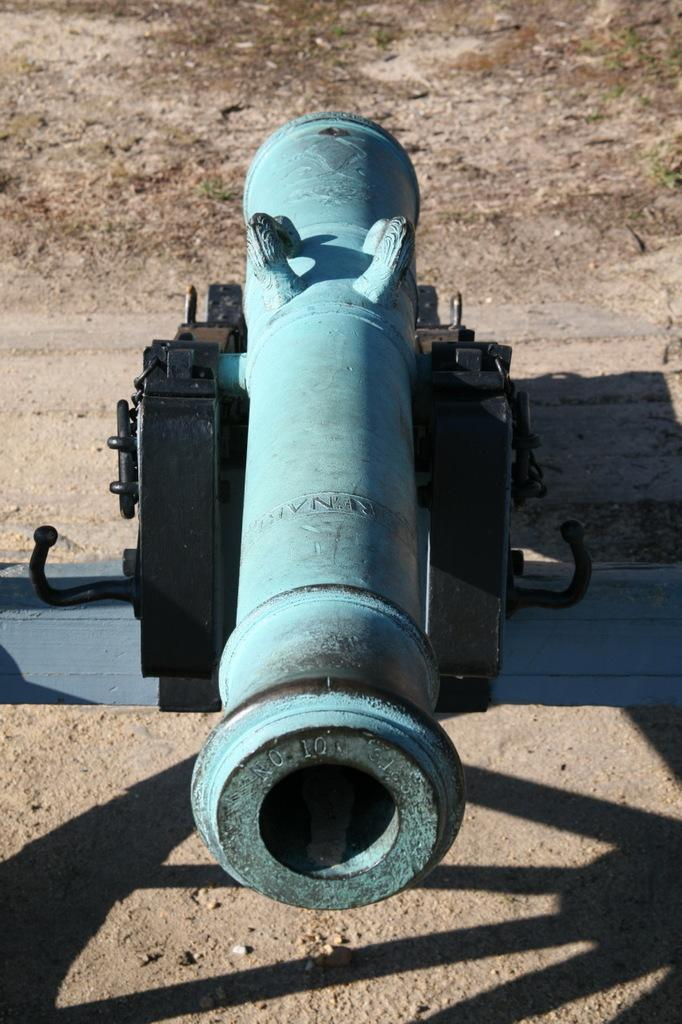What is the main object in the picture? There is a canon in the picture. What colors can be seen on the canon? The canon is blue and black in color. Where is the canon located? The canon is on the ground. Is there any indication of the canon's shadow in the picture? Yes, there is a shadow of the canon on the ground in front of it. What type of animal can be seen playing with the sand near the canon in the image? There is no animal or sand present in the image; it only features a canon on the ground with its shadow. 